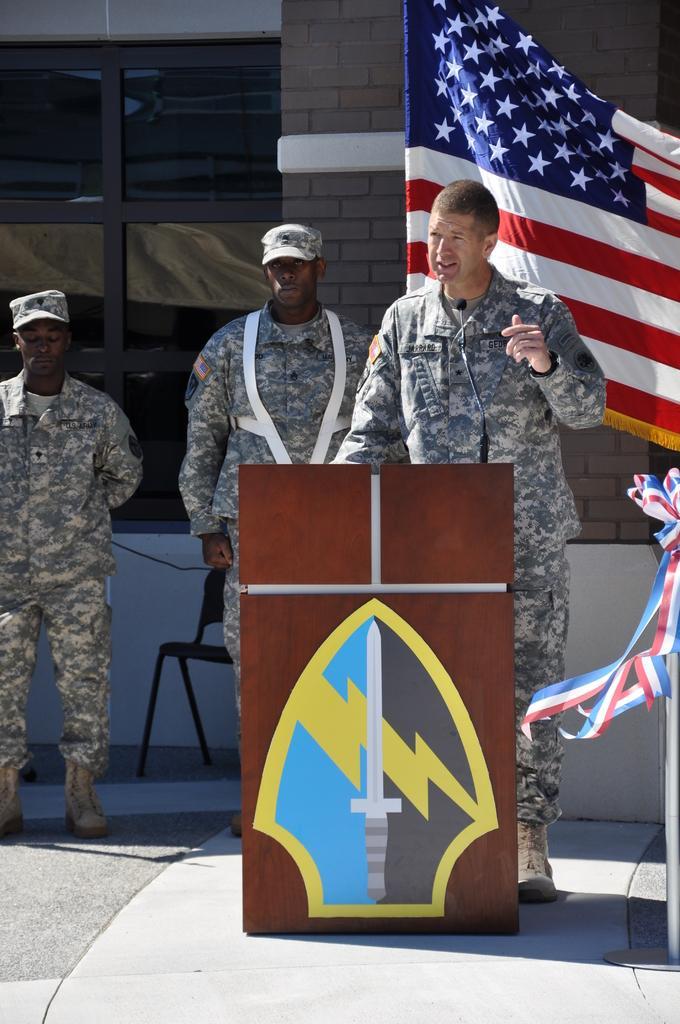How would you summarize this image in a sentence or two? In this image, we can see three persons. Here a person is standing behind the wooden podium and talking in-front of a microphone. Background we can see brick wall, flag, chair, glass window and wire. Right side of the image, we can see rod stand with ribbons on the path. 